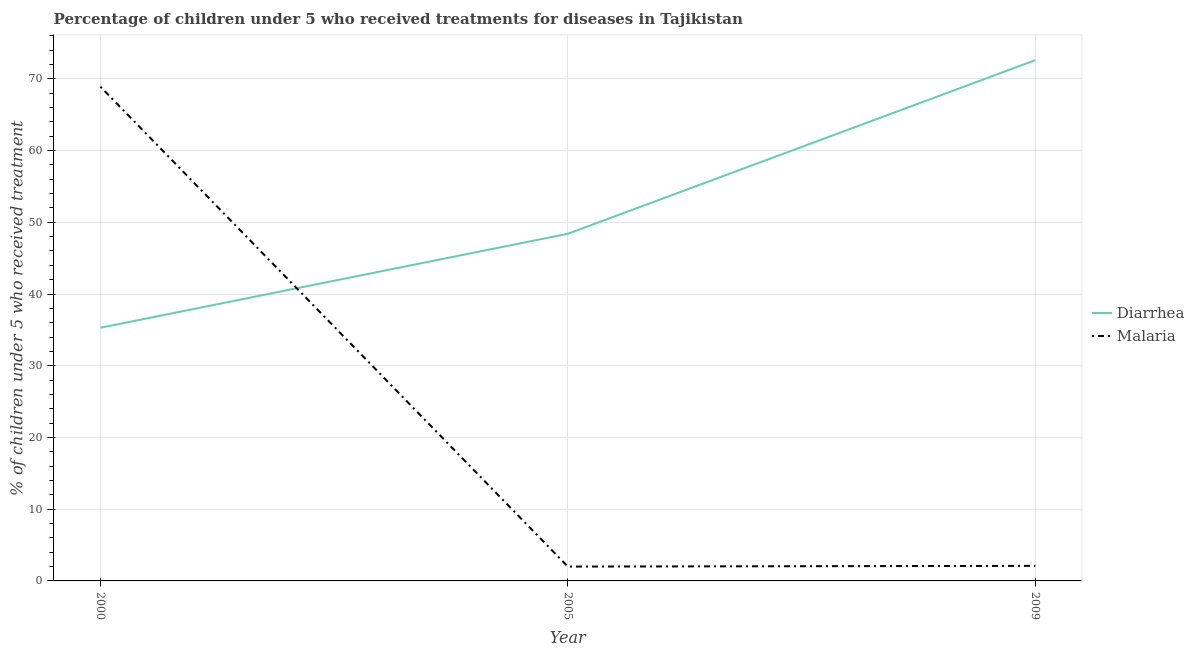Does the line corresponding to percentage of children who received treatment for diarrhoea intersect with the line corresponding to percentage of children who received treatment for malaria?
Keep it short and to the point. Yes. What is the percentage of children who received treatment for malaria in 2005?
Your answer should be very brief. 2. Across all years, what is the maximum percentage of children who received treatment for malaria?
Offer a very short reply. 68.9. Across all years, what is the minimum percentage of children who received treatment for diarrhoea?
Give a very brief answer. 35.3. In which year was the percentage of children who received treatment for malaria maximum?
Offer a very short reply. 2000. In which year was the percentage of children who received treatment for diarrhoea minimum?
Provide a short and direct response. 2000. What is the total percentage of children who received treatment for diarrhoea in the graph?
Provide a short and direct response. 156.3. What is the difference between the percentage of children who received treatment for diarrhoea in 2000 and that in 2009?
Offer a very short reply. -37.3. What is the difference between the percentage of children who received treatment for diarrhoea in 2000 and the percentage of children who received treatment for malaria in 2009?
Provide a short and direct response. 33.2. What is the average percentage of children who received treatment for diarrhoea per year?
Keep it short and to the point. 52.1. In the year 2005, what is the difference between the percentage of children who received treatment for malaria and percentage of children who received treatment for diarrhoea?
Your response must be concise. -46.4. What is the ratio of the percentage of children who received treatment for malaria in 2000 to that in 2009?
Provide a succinct answer. 32.81. Is the difference between the percentage of children who received treatment for malaria in 2000 and 2009 greater than the difference between the percentage of children who received treatment for diarrhoea in 2000 and 2009?
Provide a succinct answer. Yes. What is the difference between the highest and the second highest percentage of children who received treatment for diarrhoea?
Your answer should be compact. 24.2. What is the difference between the highest and the lowest percentage of children who received treatment for diarrhoea?
Ensure brevity in your answer.  37.3. Is the sum of the percentage of children who received treatment for malaria in 2005 and 2009 greater than the maximum percentage of children who received treatment for diarrhoea across all years?
Make the answer very short. No. Does the percentage of children who received treatment for malaria monotonically increase over the years?
Your response must be concise. No. Is the percentage of children who received treatment for diarrhoea strictly greater than the percentage of children who received treatment for malaria over the years?
Make the answer very short. No. How many lines are there?
Make the answer very short. 2. What is the difference between two consecutive major ticks on the Y-axis?
Provide a succinct answer. 10. Are the values on the major ticks of Y-axis written in scientific E-notation?
Your response must be concise. No. Does the graph contain grids?
Give a very brief answer. Yes. How many legend labels are there?
Offer a very short reply. 2. What is the title of the graph?
Provide a succinct answer. Percentage of children under 5 who received treatments for diseases in Tajikistan. Does "Export" appear as one of the legend labels in the graph?
Give a very brief answer. No. What is the label or title of the Y-axis?
Keep it short and to the point. % of children under 5 who received treatment. What is the % of children under 5 who received treatment in Diarrhea in 2000?
Keep it short and to the point. 35.3. What is the % of children under 5 who received treatment of Malaria in 2000?
Keep it short and to the point. 68.9. What is the % of children under 5 who received treatment of Diarrhea in 2005?
Provide a succinct answer. 48.4. What is the % of children under 5 who received treatment in Malaria in 2005?
Your response must be concise. 2. What is the % of children under 5 who received treatment of Diarrhea in 2009?
Ensure brevity in your answer.  72.6. Across all years, what is the maximum % of children under 5 who received treatment in Diarrhea?
Offer a very short reply. 72.6. Across all years, what is the maximum % of children under 5 who received treatment of Malaria?
Give a very brief answer. 68.9. Across all years, what is the minimum % of children under 5 who received treatment in Diarrhea?
Your answer should be compact. 35.3. What is the total % of children under 5 who received treatment in Diarrhea in the graph?
Provide a short and direct response. 156.3. What is the total % of children under 5 who received treatment of Malaria in the graph?
Your answer should be compact. 73. What is the difference between the % of children under 5 who received treatment of Diarrhea in 2000 and that in 2005?
Provide a short and direct response. -13.1. What is the difference between the % of children under 5 who received treatment in Malaria in 2000 and that in 2005?
Make the answer very short. 66.9. What is the difference between the % of children under 5 who received treatment in Diarrhea in 2000 and that in 2009?
Your answer should be compact. -37.3. What is the difference between the % of children under 5 who received treatment of Malaria in 2000 and that in 2009?
Provide a short and direct response. 66.8. What is the difference between the % of children under 5 who received treatment in Diarrhea in 2005 and that in 2009?
Your answer should be very brief. -24.2. What is the difference between the % of children under 5 who received treatment of Diarrhea in 2000 and the % of children under 5 who received treatment of Malaria in 2005?
Your response must be concise. 33.3. What is the difference between the % of children under 5 who received treatment of Diarrhea in 2000 and the % of children under 5 who received treatment of Malaria in 2009?
Your response must be concise. 33.2. What is the difference between the % of children under 5 who received treatment in Diarrhea in 2005 and the % of children under 5 who received treatment in Malaria in 2009?
Ensure brevity in your answer.  46.3. What is the average % of children under 5 who received treatment of Diarrhea per year?
Provide a short and direct response. 52.1. What is the average % of children under 5 who received treatment of Malaria per year?
Make the answer very short. 24.33. In the year 2000, what is the difference between the % of children under 5 who received treatment of Diarrhea and % of children under 5 who received treatment of Malaria?
Provide a short and direct response. -33.6. In the year 2005, what is the difference between the % of children under 5 who received treatment of Diarrhea and % of children under 5 who received treatment of Malaria?
Offer a terse response. 46.4. In the year 2009, what is the difference between the % of children under 5 who received treatment in Diarrhea and % of children under 5 who received treatment in Malaria?
Provide a succinct answer. 70.5. What is the ratio of the % of children under 5 who received treatment in Diarrhea in 2000 to that in 2005?
Your answer should be compact. 0.73. What is the ratio of the % of children under 5 who received treatment in Malaria in 2000 to that in 2005?
Ensure brevity in your answer.  34.45. What is the ratio of the % of children under 5 who received treatment in Diarrhea in 2000 to that in 2009?
Provide a succinct answer. 0.49. What is the ratio of the % of children under 5 who received treatment of Malaria in 2000 to that in 2009?
Provide a succinct answer. 32.81. What is the ratio of the % of children under 5 who received treatment of Diarrhea in 2005 to that in 2009?
Your answer should be compact. 0.67. What is the difference between the highest and the second highest % of children under 5 who received treatment in Diarrhea?
Your answer should be very brief. 24.2. What is the difference between the highest and the second highest % of children under 5 who received treatment in Malaria?
Your answer should be very brief. 66.8. What is the difference between the highest and the lowest % of children under 5 who received treatment of Diarrhea?
Keep it short and to the point. 37.3. What is the difference between the highest and the lowest % of children under 5 who received treatment in Malaria?
Make the answer very short. 66.9. 